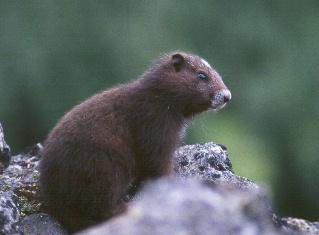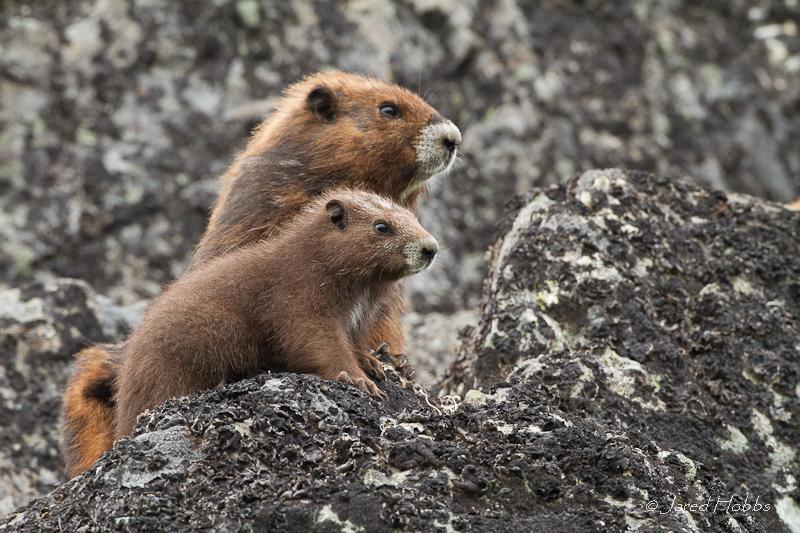The first image is the image on the left, the second image is the image on the right. Examine the images to the left and right. Is the description "There are a total of 3 young capybara." accurate? Answer yes or no. Yes. The first image is the image on the left, the second image is the image on the right. For the images displayed, is the sentence "there are 3 gophers on rocky surfaces in the image pair" factually correct? Answer yes or no. Yes. 